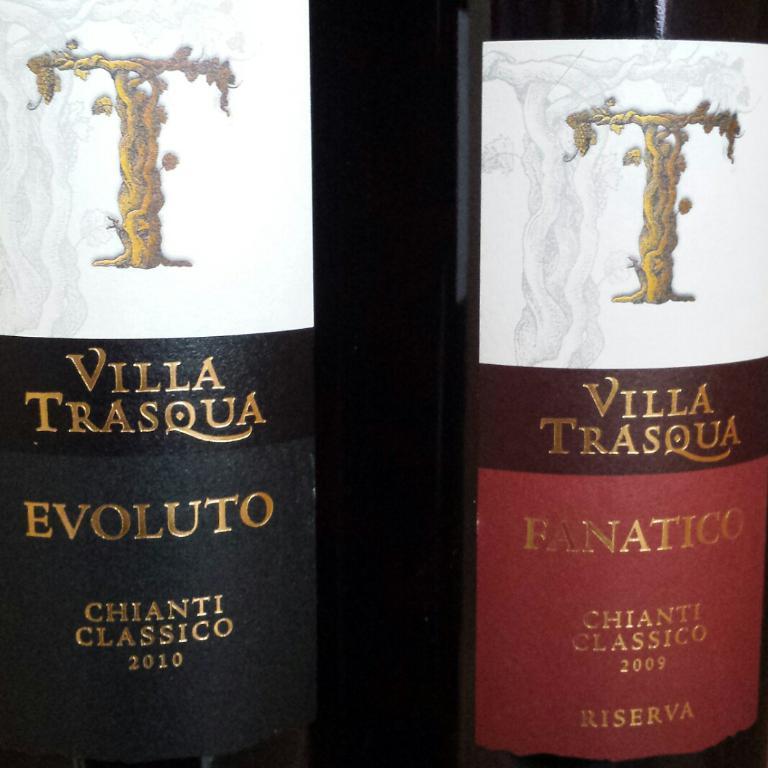What year are these wines from?
Give a very brief answer. 2010 and 2009. 